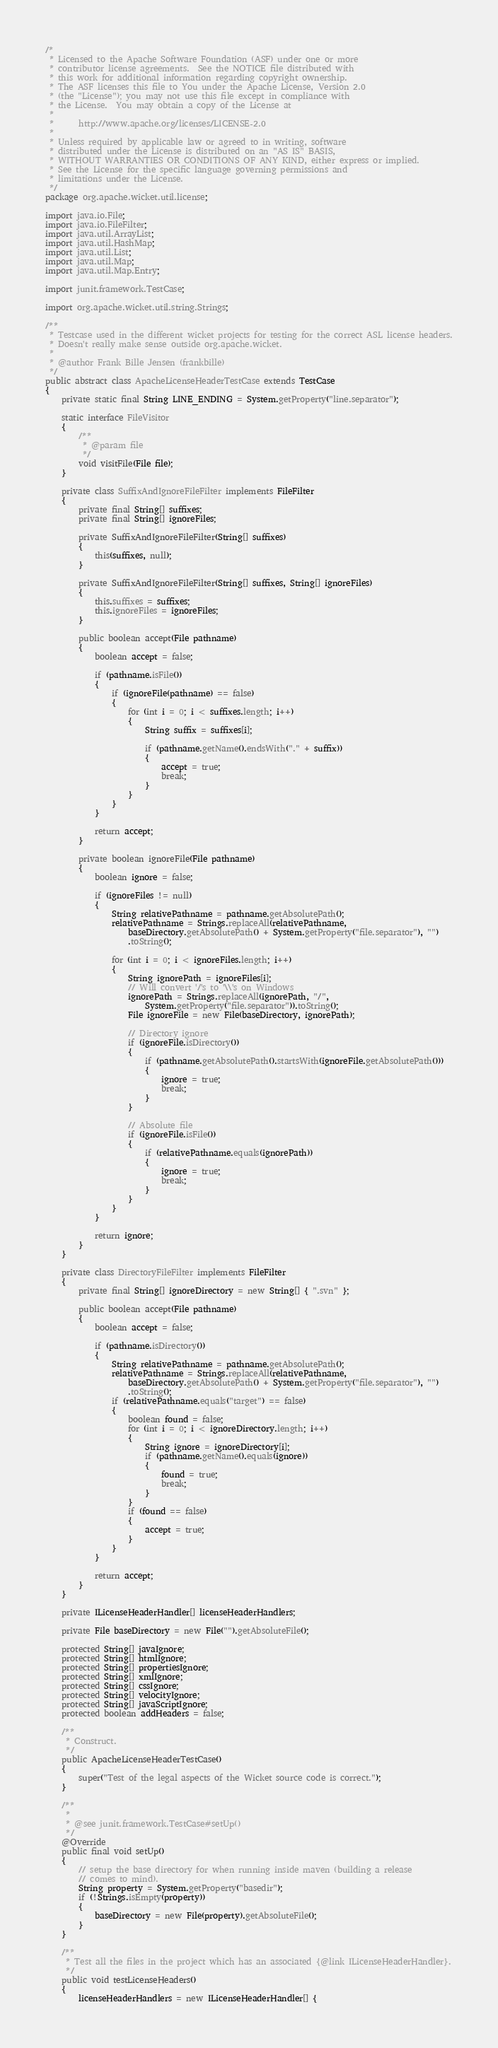<code> <loc_0><loc_0><loc_500><loc_500><_Java_>/*
 * Licensed to the Apache Software Foundation (ASF) under one or more
 * contributor license agreements.  See the NOTICE file distributed with
 * this work for additional information regarding copyright ownership.
 * The ASF licenses this file to You under the Apache License, Version 2.0
 * (the "License"); you may not use this file except in compliance with
 * the License.  You may obtain a copy of the License at
 *
 *      http://www.apache.org/licenses/LICENSE-2.0
 *
 * Unless required by applicable law or agreed to in writing, software
 * distributed under the License is distributed on an "AS IS" BASIS,
 * WITHOUT WARRANTIES OR CONDITIONS OF ANY KIND, either express or implied.
 * See the License for the specific language governing permissions and
 * limitations under the License.
 */
package org.apache.wicket.util.license;

import java.io.File;
import java.io.FileFilter;
import java.util.ArrayList;
import java.util.HashMap;
import java.util.List;
import java.util.Map;
import java.util.Map.Entry;

import junit.framework.TestCase;

import org.apache.wicket.util.string.Strings;

/**
 * Testcase used in the different wicket projects for testing for the correct ASL license headers.
 * Doesn't really make sense outside org.apache.wicket.
 * 
 * @author Frank Bille Jensen (frankbille)
 */
public abstract class ApacheLicenseHeaderTestCase extends TestCase
{
	private static final String LINE_ENDING = System.getProperty("line.separator");

	static interface FileVisitor
	{
		/**
		 * @param file
		 */
		void visitFile(File file);
	}

	private class SuffixAndIgnoreFileFilter implements FileFilter
	{
		private final String[] suffixes;
		private final String[] ignoreFiles;

		private SuffixAndIgnoreFileFilter(String[] suffixes)
		{
			this(suffixes, null);
		}

		private SuffixAndIgnoreFileFilter(String[] suffixes, String[] ignoreFiles)
		{
			this.suffixes = suffixes;
			this.ignoreFiles = ignoreFiles;
		}

		public boolean accept(File pathname)
		{
			boolean accept = false;

			if (pathname.isFile())
			{
				if (ignoreFile(pathname) == false)
				{
					for (int i = 0; i < suffixes.length; i++)
					{
						String suffix = suffixes[i];

						if (pathname.getName().endsWith("." + suffix))
						{
							accept = true;
							break;
						}
					}
				}
			}

			return accept;
		}

		private boolean ignoreFile(File pathname)
		{
			boolean ignore = false;

			if (ignoreFiles != null)
			{
				String relativePathname = pathname.getAbsolutePath();
				relativePathname = Strings.replaceAll(relativePathname,
					baseDirectory.getAbsolutePath() + System.getProperty("file.separator"), "")
					.toString();

				for (int i = 0; i < ignoreFiles.length; i++)
				{
					String ignorePath = ignoreFiles[i];
					// Will convert '/'s to '\\'s on Windows
					ignorePath = Strings.replaceAll(ignorePath, "/",
						System.getProperty("file.separator")).toString();
					File ignoreFile = new File(baseDirectory, ignorePath);

					// Directory ignore
					if (ignoreFile.isDirectory())
					{
						if (pathname.getAbsolutePath().startsWith(ignoreFile.getAbsolutePath()))
						{
							ignore = true;
							break;
						}
					}

					// Absolute file
					if (ignoreFile.isFile())
					{
						if (relativePathname.equals(ignorePath))
						{
							ignore = true;
							break;
						}
					}
				}
			}

			return ignore;
		}
	}

	private class DirectoryFileFilter implements FileFilter
	{
		private final String[] ignoreDirectory = new String[] { ".svn" };

		public boolean accept(File pathname)
		{
			boolean accept = false;

			if (pathname.isDirectory())
			{
				String relativePathname = pathname.getAbsolutePath();
				relativePathname = Strings.replaceAll(relativePathname,
					baseDirectory.getAbsolutePath() + System.getProperty("file.separator"), "")
					.toString();
				if (relativePathname.equals("target") == false)
				{
					boolean found = false;
					for (int i = 0; i < ignoreDirectory.length; i++)
					{
						String ignore = ignoreDirectory[i];
						if (pathname.getName().equals(ignore))
						{
							found = true;
							break;
						}
					}
					if (found == false)
					{
						accept = true;
					}
				}
			}

			return accept;
		}
	}

	private ILicenseHeaderHandler[] licenseHeaderHandlers;

	private File baseDirectory = new File("").getAbsoluteFile();

	protected String[] javaIgnore;
	protected String[] htmlIgnore;
	protected String[] propertiesIgnore;
	protected String[] xmlIgnore;
	protected String[] cssIgnore;
	protected String[] velocityIgnore;
	protected String[] javaScriptIgnore;
	protected boolean addHeaders = false;

	/**
	 * Construct.
	 */
	public ApacheLicenseHeaderTestCase()
	{
		super("Test of the legal aspects of the Wicket source code is correct.");
	}

	/**
	 * 
	 * @see junit.framework.TestCase#setUp()
	 */
	@Override
	public final void setUp()
	{
		// setup the base directory for when running inside maven (building a release
		// comes to mind).
		String property = System.getProperty("basedir");
		if (!Strings.isEmpty(property))
		{
			baseDirectory = new File(property).getAbsoluteFile();
		}
	}

	/**
	 * Test all the files in the project which has an associated {@link ILicenseHeaderHandler}.
	 */
	public void testLicenseHeaders()
	{
		licenseHeaderHandlers = new ILicenseHeaderHandler[] {</code> 